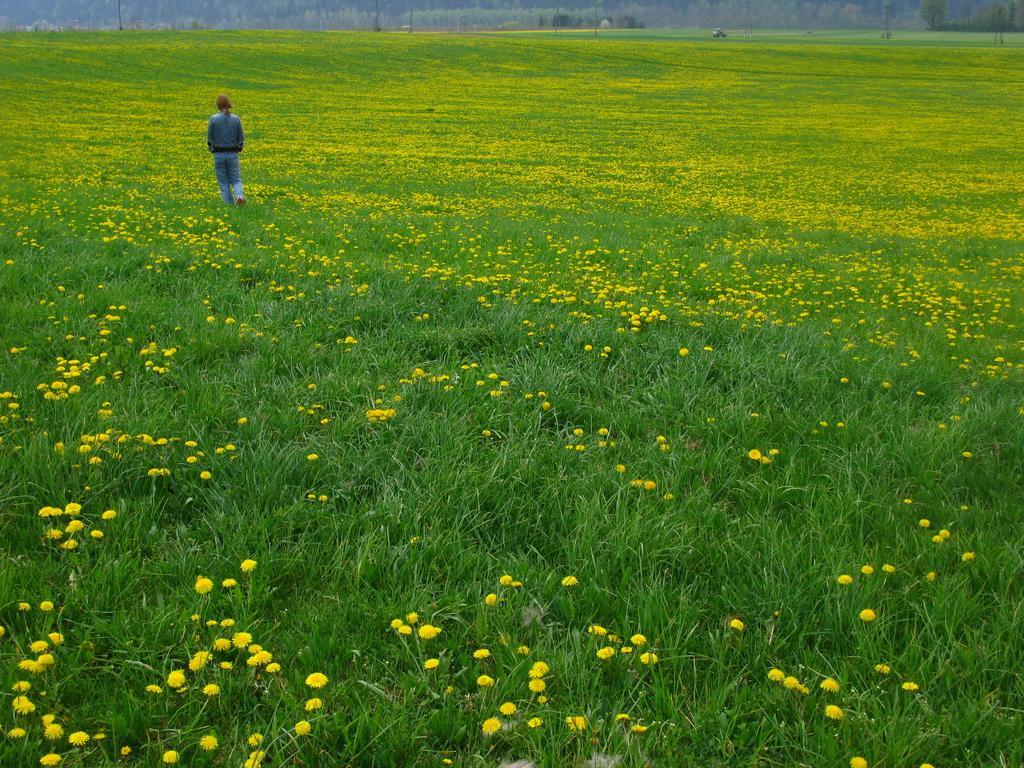Can you describe this image briefly? In this picture, we see the flower fields. These flowers are in yellow color. In the middle, we see a woman is walking. In the background, we see the poles. There are trees in the background. 